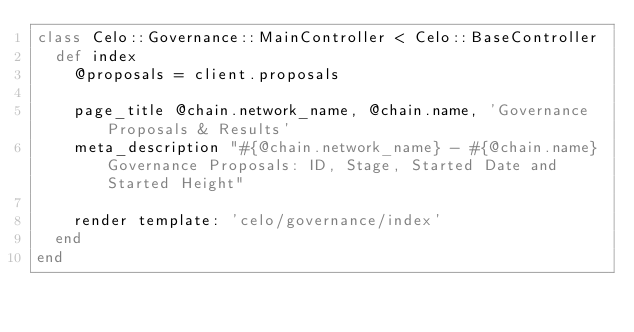<code> <loc_0><loc_0><loc_500><loc_500><_Ruby_>class Celo::Governance::MainController < Celo::BaseController
  def index
    @proposals = client.proposals

    page_title @chain.network_name, @chain.name, 'Governance Proposals & Results'
    meta_description "#{@chain.network_name} - #{@chain.name} Governance Proposals: ID, Stage, Started Date and Started Height"

    render template: 'celo/governance/index'
  end
end
</code> 